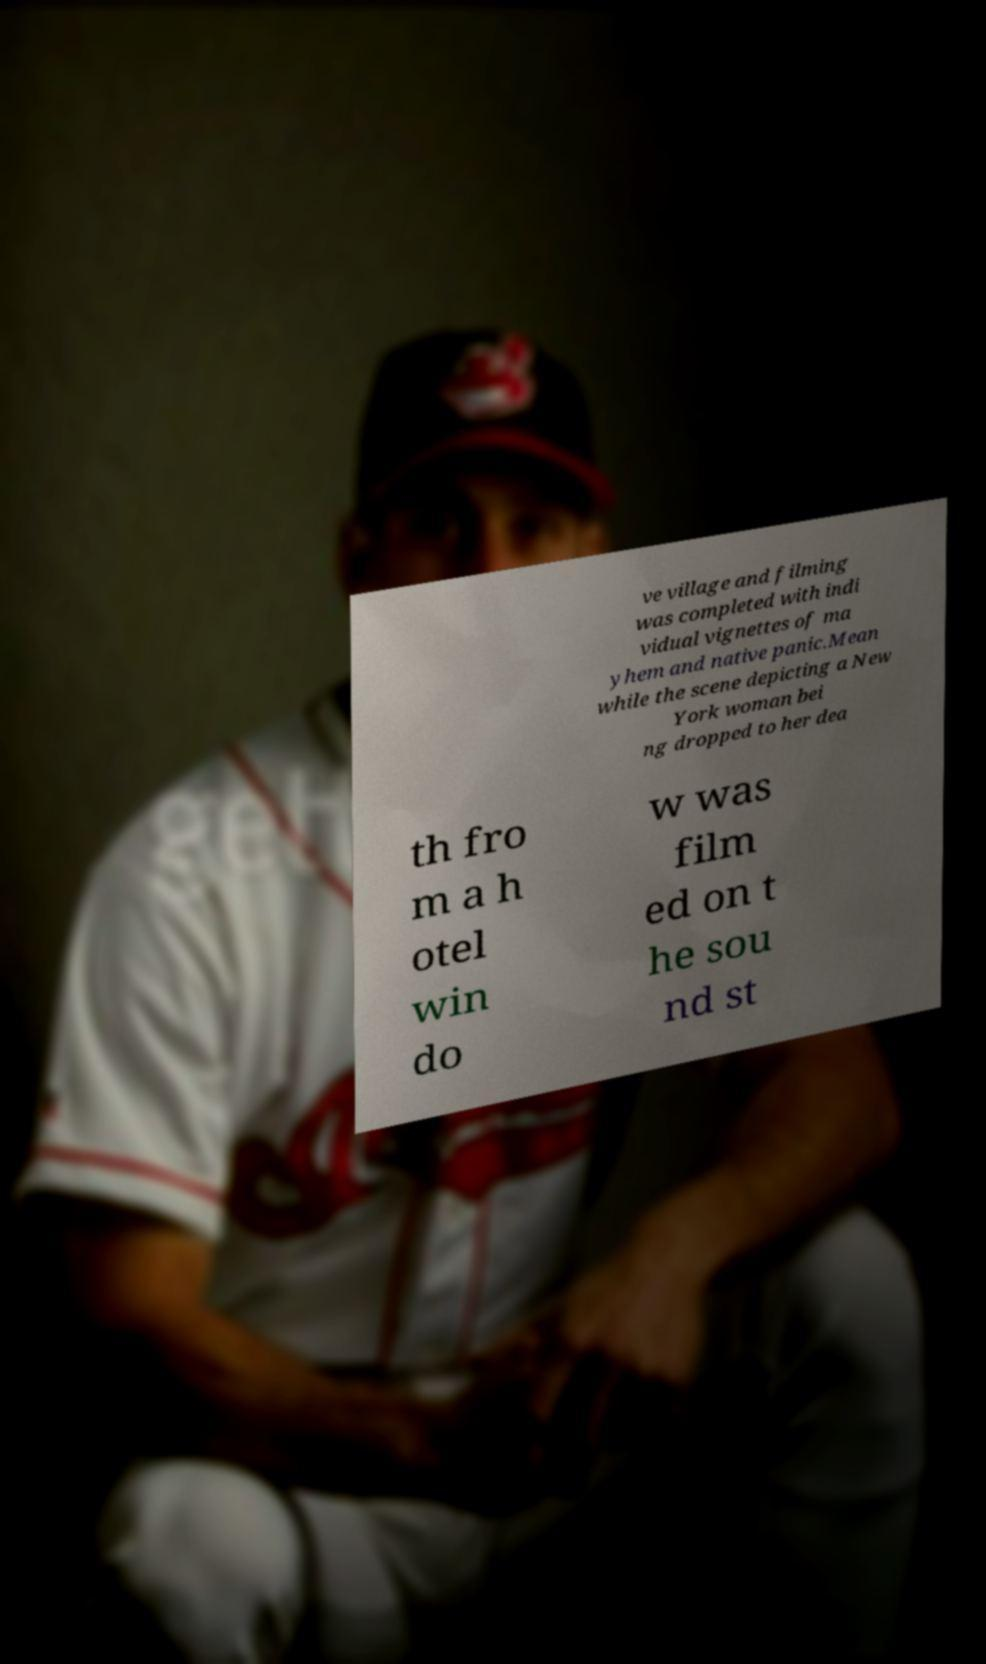For documentation purposes, I need the text within this image transcribed. Could you provide that? ve village and filming was completed with indi vidual vignettes of ma yhem and native panic.Mean while the scene depicting a New York woman bei ng dropped to her dea th fro m a h otel win do w was film ed on t he sou nd st 